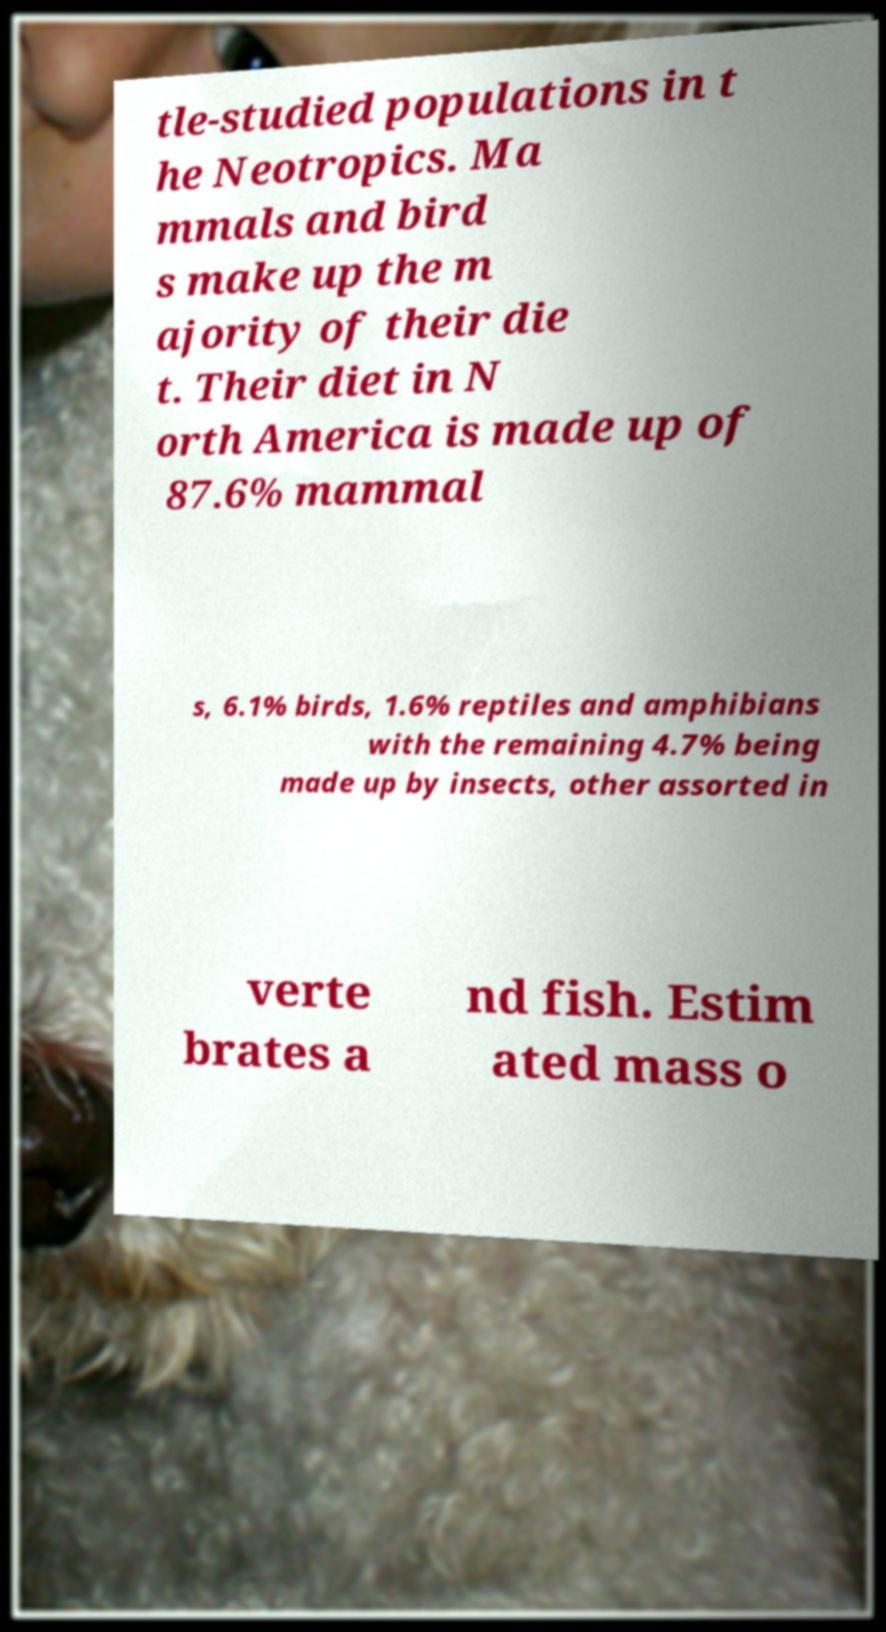For documentation purposes, I need the text within this image transcribed. Could you provide that? tle-studied populations in t he Neotropics. Ma mmals and bird s make up the m ajority of their die t. Their diet in N orth America is made up of 87.6% mammal s, 6.1% birds, 1.6% reptiles and amphibians with the remaining 4.7% being made up by insects, other assorted in verte brates a nd fish. Estim ated mass o 